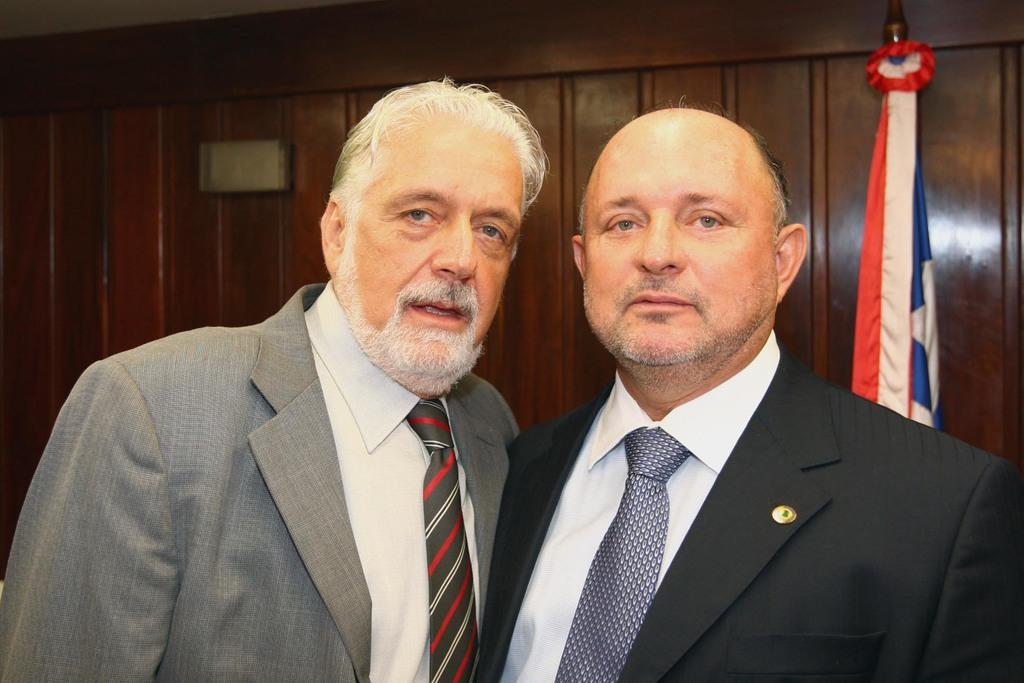How many people are in the image? There are two men standing in the image. What can be seen on the right side of the image? There is a flag on the right side of the image. How is the flag positioned in the image? The flag is hanging from a pole. What type of structure is visible in the background of the image? There is a wooden wall in the background of the image. What type of test is being conducted in the lunchroom in the image? There is no lunchroom or test present in the image; it features two men and a flag hanging from a pole. 